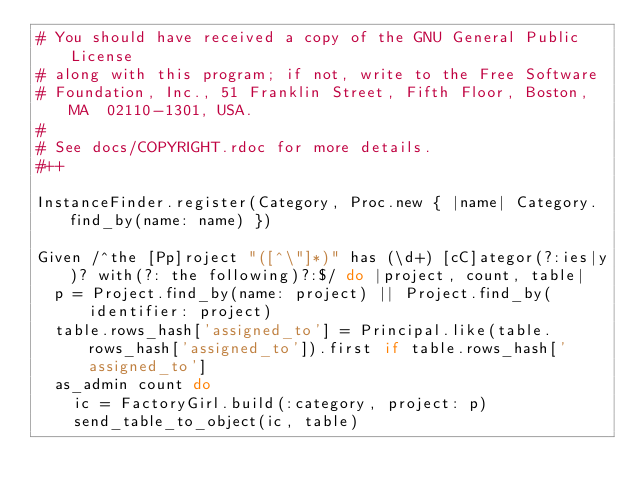<code> <loc_0><loc_0><loc_500><loc_500><_Ruby_># You should have received a copy of the GNU General Public License
# along with this program; if not, write to the Free Software
# Foundation, Inc., 51 Franklin Street, Fifth Floor, Boston, MA  02110-1301, USA.
#
# See docs/COPYRIGHT.rdoc for more details.
#++

InstanceFinder.register(Category, Proc.new { |name| Category.find_by(name: name) })

Given /^the [Pp]roject "([^\"]*)" has (\d+) [cC]ategor(?:ies|y)? with(?: the following)?:$/ do |project, count, table|
  p = Project.find_by(name: project) || Project.find_by(identifier: project)
  table.rows_hash['assigned_to'] = Principal.like(table.rows_hash['assigned_to']).first if table.rows_hash['assigned_to']
  as_admin count do
    ic = FactoryGirl.build(:category, project: p)
    send_table_to_object(ic, table)</code> 